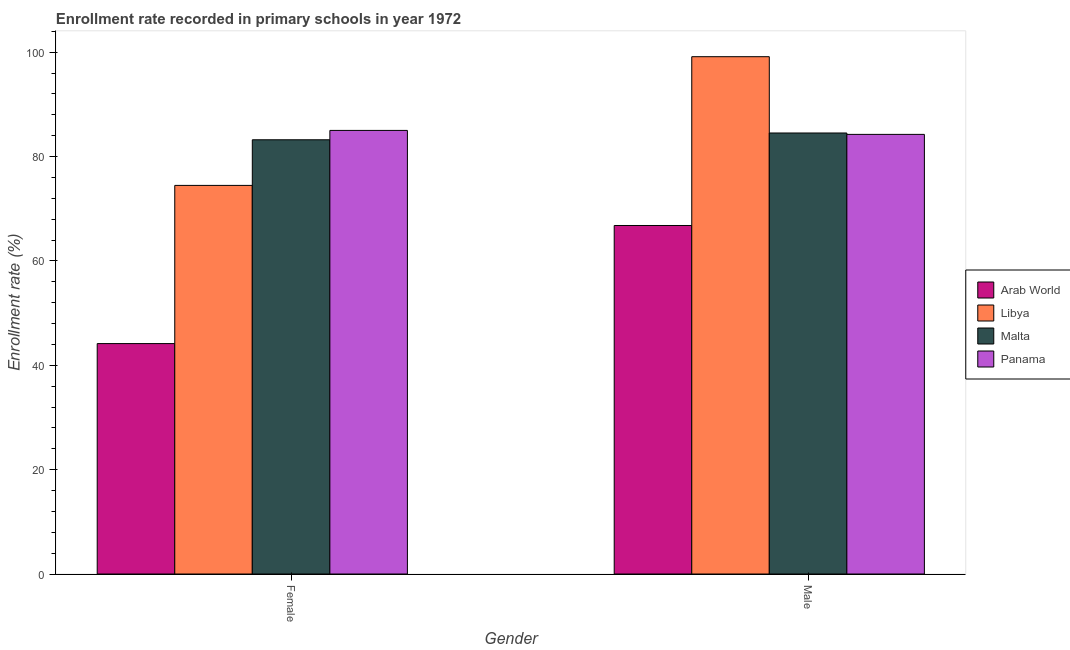How many different coloured bars are there?
Offer a very short reply. 4. How many bars are there on the 2nd tick from the left?
Provide a short and direct response. 4. What is the label of the 2nd group of bars from the left?
Your answer should be compact. Male. What is the enrollment rate of male students in Panama?
Keep it short and to the point. 84.26. Across all countries, what is the maximum enrollment rate of female students?
Offer a terse response. 85.02. Across all countries, what is the minimum enrollment rate of female students?
Make the answer very short. 44.16. In which country was the enrollment rate of female students maximum?
Provide a short and direct response. Panama. In which country was the enrollment rate of male students minimum?
Provide a short and direct response. Arab World. What is the total enrollment rate of female students in the graph?
Provide a short and direct response. 286.89. What is the difference between the enrollment rate of male students in Panama and that in Malta?
Keep it short and to the point. -0.27. What is the difference between the enrollment rate of female students in Panama and the enrollment rate of male students in Arab World?
Provide a succinct answer. 18.22. What is the average enrollment rate of male students per country?
Ensure brevity in your answer.  83.68. What is the difference between the enrollment rate of male students and enrollment rate of female students in Libya?
Give a very brief answer. 24.67. What is the ratio of the enrollment rate of female students in Libya to that in Panama?
Ensure brevity in your answer.  0.88. Is the enrollment rate of male students in Malta less than that in Panama?
Your response must be concise. No. In how many countries, is the enrollment rate of female students greater than the average enrollment rate of female students taken over all countries?
Your answer should be very brief. 3. What does the 3rd bar from the left in Male represents?
Offer a very short reply. Malta. What does the 1st bar from the right in Female represents?
Ensure brevity in your answer.  Panama. How many bars are there?
Provide a short and direct response. 8. How many countries are there in the graph?
Your response must be concise. 4. Where does the legend appear in the graph?
Your response must be concise. Center right. How many legend labels are there?
Your answer should be compact. 4. How are the legend labels stacked?
Make the answer very short. Vertical. What is the title of the graph?
Your response must be concise. Enrollment rate recorded in primary schools in year 1972. Does "St. Kitts and Nevis" appear as one of the legend labels in the graph?
Ensure brevity in your answer.  No. What is the label or title of the X-axis?
Give a very brief answer. Gender. What is the label or title of the Y-axis?
Offer a terse response. Enrollment rate (%). What is the Enrollment rate (%) in Arab World in Female?
Your response must be concise. 44.16. What is the Enrollment rate (%) in Libya in Female?
Make the answer very short. 74.48. What is the Enrollment rate (%) in Malta in Female?
Make the answer very short. 83.22. What is the Enrollment rate (%) of Panama in Female?
Offer a very short reply. 85.02. What is the Enrollment rate (%) of Arab World in Male?
Provide a short and direct response. 66.8. What is the Enrollment rate (%) of Libya in Male?
Your response must be concise. 99.15. What is the Enrollment rate (%) in Malta in Male?
Give a very brief answer. 84.52. What is the Enrollment rate (%) in Panama in Male?
Provide a short and direct response. 84.26. Across all Gender, what is the maximum Enrollment rate (%) in Arab World?
Your response must be concise. 66.8. Across all Gender, what is the maximum Enrollment rate (%) of Libya?
Keep it short and to the point. 99.15. Across all Gender, what is the maximum Enrollment rate (%) of Malta?
Give a very brief answer. 84.52. Across all Gender, what is the maximum Enrollment rate (%) of Panama?
Ensure brevity in your answer.  85.02. Across all Gender, what is the minimum Enrollment rate (%) of Arab World?
Provide a short and direct response. 44.16. Across all Gender, what is the minimum Enrollment rate (%) in Libya?
Offer a terse response. 74.48. Across all Gender, what is the minimum Enrollment rate (%) of Malta?
Your answer should be compact. 83.22. Across all Gender, what is the minimum Enrollment rate (%) in Panama?
Offer a very short reply. 84.26. What is the total Enrollment rate (%) of Arab World in the graph?
Offer a terse response. 110.96. What is the total Enrollment rate (%) of Libya in the graph?
Provide a succinct answer. 173.63. What is the total Enrollment rate (%) in Malta in the graph?
Your response must be concise. 167.75. What is the total Enrollment rate (%) of Panama in the graph?
Keep it short and to the point. 169.28. What is the difference between the Enrollment rate (%) of Arab World in Female and that in Male?
Your response must be concise. -22.63. What is the difference between the Enrollment rate (%) of Libya in Female and that in Male?
Ensure brevity in your answer.  -24.67. What is the difference between the Enrollment rate (%) in Malta in Female and that in Male?
Your answer should be very brief. -1.3. What is the difference between the Enrollment rate (%) of Panama in Female and that in Male?
Offer a terse response. 0.76. What is the difference between the Enrollment rate (%) of Arab World in Female and the Enrollment rate (%) of Libya in Male?
Offer a very short reply. -54.99. What is the difference between the Enrollment rate (%) in Arab World in Female and the Enrollment rate (%) in Malta in Male?
Offer a terse response. -40.36. What is the difference between the Enrollment rate (%) of Arab World in Female and the Enrollment rate (%) of Panama in Male?
Your answer should be very brief. -40.1. What is the difference between the Enrollment rate (%) in Libya in Female and the Enrollment rate (%) in Malta in Male?
Give a very brief answer. -10.04. What is the difference between the Enrollment rate (%) of Libya in Female and the Enrollment rate (%) of Panama in Male?
Provide a short and direct response. -9.78. What is the difference between the Enrollment rate (%) of Malta in Female and the Enrollment rate (%) of Panama in Male?
Ensure brevity in your answer.  -1.03. What is the average Enrollment rate (%) in Arab World per Gender?
Give a very brief answer. 55.48. What is the average Enrollment rate (%) of Libya per Gender?
Offer a terse response. 86.81. What is the average Enrollment rate (%) of Malta per Gender?
Keep it short and to the point. 83.87. What is the average Enrollment rate (%) of Panama per Gender?
Offer a very short reply. 84.64. What is the difference between the Enrollment rate (%) in Arab World and Enrollment rate (%) in Libya in Female?
Provide a succinct answer. -30.32. What is the difference between the Enrollment rate (%) of Arab World and Enrollment rate (%) of Malta in Female?
Make the answer very short. -39.06. What is the difference between the Enrollment rate (%) in Arab World and Enrollment rate (%) in Panama in Female?
Offer a terse response. -40.86. What is the difference between the Enrollment rate (%) of Libya and Enrollment rate (%) of Malta in Female?
Give a very brief answer. -8.74. What is the difference between the Enrollment rate (%) in Libya and Enrollment rate (%) in Panama in Female?
Your answer should be very brief. -10.54. What is the difference between the Enrollment rate (%) in Malta and Enrollment rate (%) in Panama in Female?
Ensure brevity in your answer.  -1.8. What is the difference between the Enrollment rate (%) in Arab World and Enrollment rate (%) in Libya in Male?
Ensure brevity in your answer.  -32.35. What is the difference between the Enrollment rate (%) in Arab World and Enrollment rate (%) in Malta in Male?
Give a very brief answer. -17.73. What is the difference between the Enrollment rate (%) of Arab World and Enrollment rate (%) of Panama in Male?
Offer a very short reply. -17.46. What is the difference between the Enrollment rate (%) of Libya and Enrollment rate (%) of Malta in Male?
Make the answer very short. 14.63. What is the difference between the Enrollment rate (%) in Libya and Enrollment rate (%) in Panama in Male?
Your answer should be very brief. 14.89. What is the difference between the Enrollment rate (%) of Malta and Enrollment rate (%) of Panama in Male?
Give a very brief answer. 0.27. What is the ratio of the Enrollment rate (%) in Arab World in Female to that in Male?
Keep it short and to the point. 0.66. What is the ratio of the Enrollment rate (%) of Libya in Female to that in Male?
Ensure brevity in your answer.  0.75. What is the ratio of the Enrollment rate (%) of Malta in Female to that in Male?
Offer a terse response. 0.98. What is the ratio of the Enrollment rate (%) of Panama in Female to that in Male?
Your answer should be very brief. 1.01. What is the difference between the highest and the second highest Enrollment rate (%) of Arab World?
Your answer should be very brief. 22.63. What is the difference between the highest and the second highest Enrollment rate (%) of Libya?
Offer a very short reply. 24.67. What is the difference between the highest and the second highest Enrollment rate (%) of Malta?
Give a very brief answer. 1.3. What is the difference between the highest and the second highest Enrollment rate (%) of Panama?
Your answer should be compact. 0.76. What is the difference between the highest and the lowest Enrollment rate (%) in Arab World?
Offer a very short reply. 22.63. What is the difference between the highest and the lowest Enrollment rate (%) of Libya?
Provide a short and direct response. 24.67. What is the difference between the highest and the lowest Enrollment rate (%) of Malta?
Offer a terse response. 1.3. What is the difference between the highest and the lowest Enrollment rate (%) of Panama?
Offer a terse response. 0.76. 